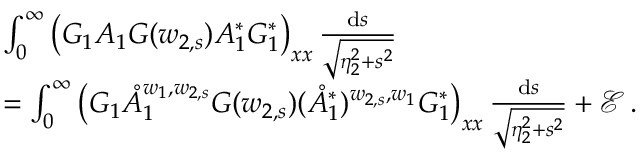<formula> <loc_0><loc_0><loc_500><loc_500>\begin{array} { r l } & { \int _ { 0 } ^ { \infty } \left ( G _ { 1 } A _ { 1 } G ( w _ { 2 , s } ) A _ { 1 } ^ { * } G _ { 1 } ^ { * } \right ) _ { x x } \, \frac { d s } { \sqrt { \eta _ { 2 } ^ { 2 } + s ^ { 2 } } } } \\ & { = \int _ { 0 } ^ { \infty } \left ( G _ { 1 } \mathring { A } _ { 1 } ^ { w _ { 1 } , w _ { 2 , s } } G ( w _ { 2 , s } ) ( \mathring { A } _ { 1 } ^ { * } ) ^ { w _ { 2 , s } , w _ { 1 } } G _ { 1 } ^ { * } \right ) _ { x x } \, \frac { d s } { \sqrt { \eta _ { 2 } ^ { 2 } + s ^ { 2 } } } + \mathcal { E } \, . } \end{array}</formula> 